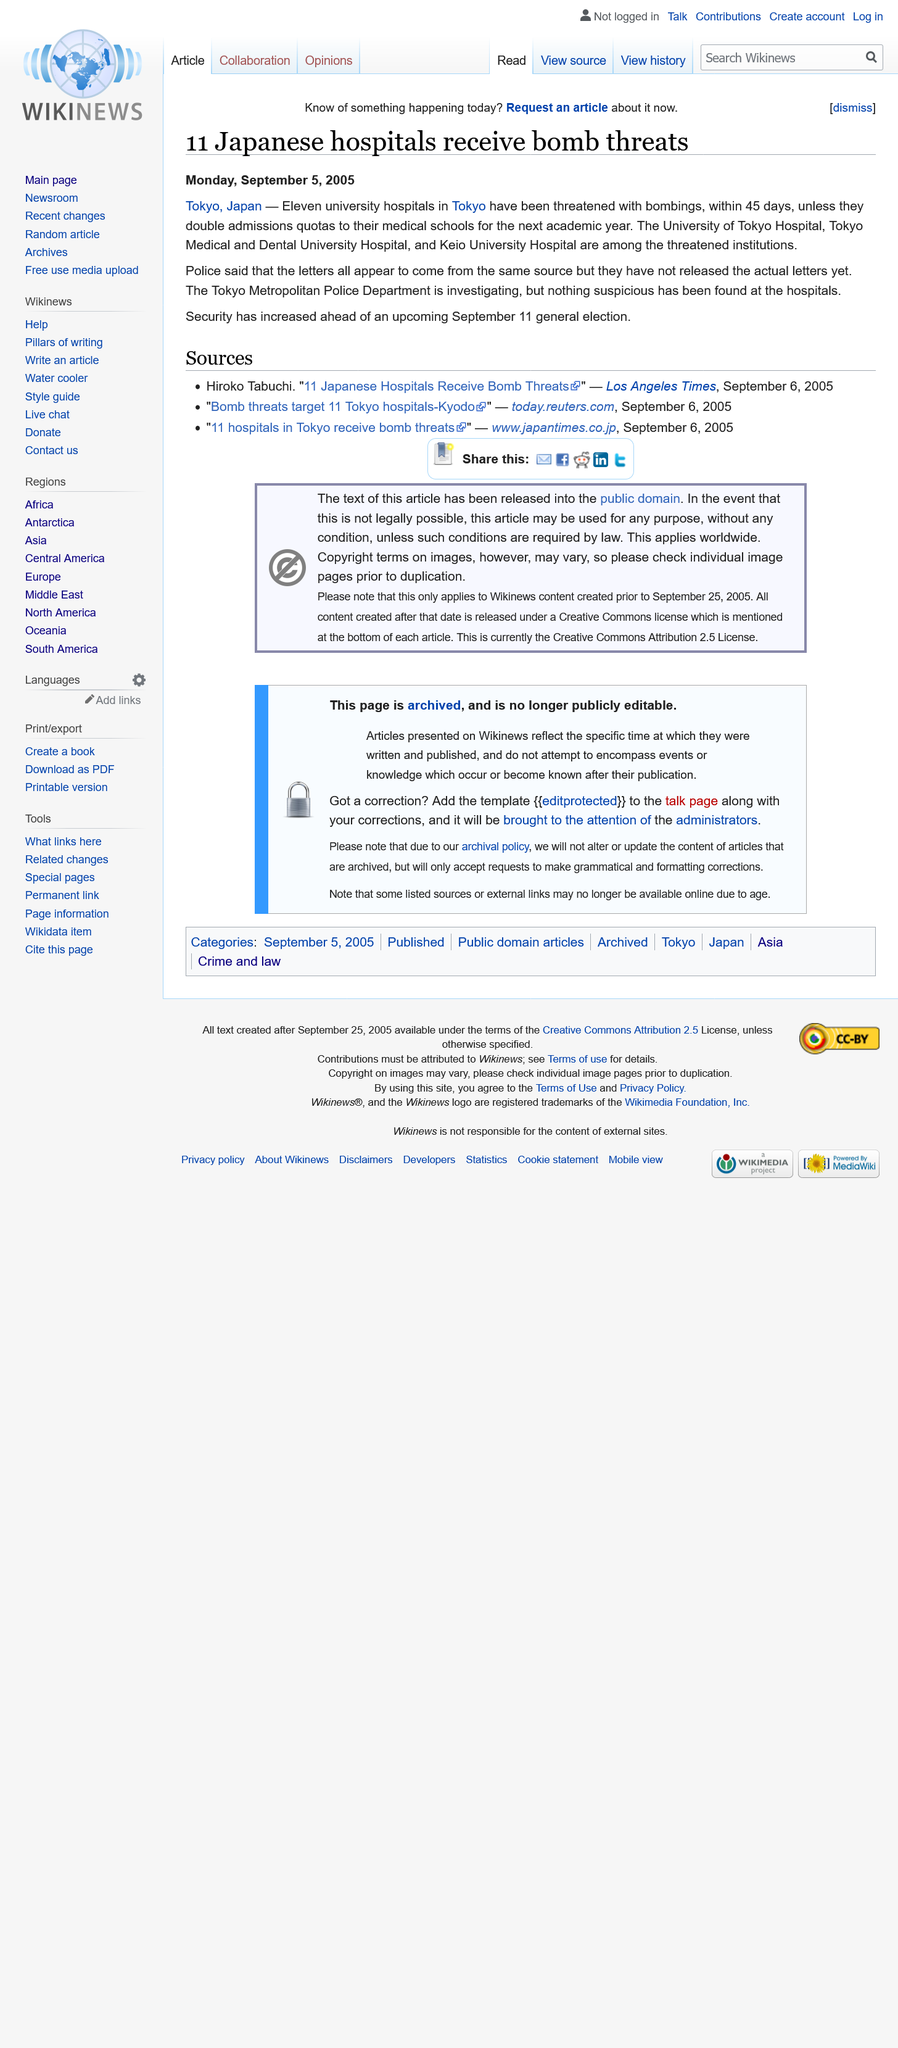Point out several critical features in this image. On Monday, September 5, 2005, a report regarding Japanese hospitals receiving bomb threats was issued. The Tokyo Metropolitan Police Department is investigating the bomb threats in Japan. It has been reported that 11 hospitals in Japan have received bomb threats. 